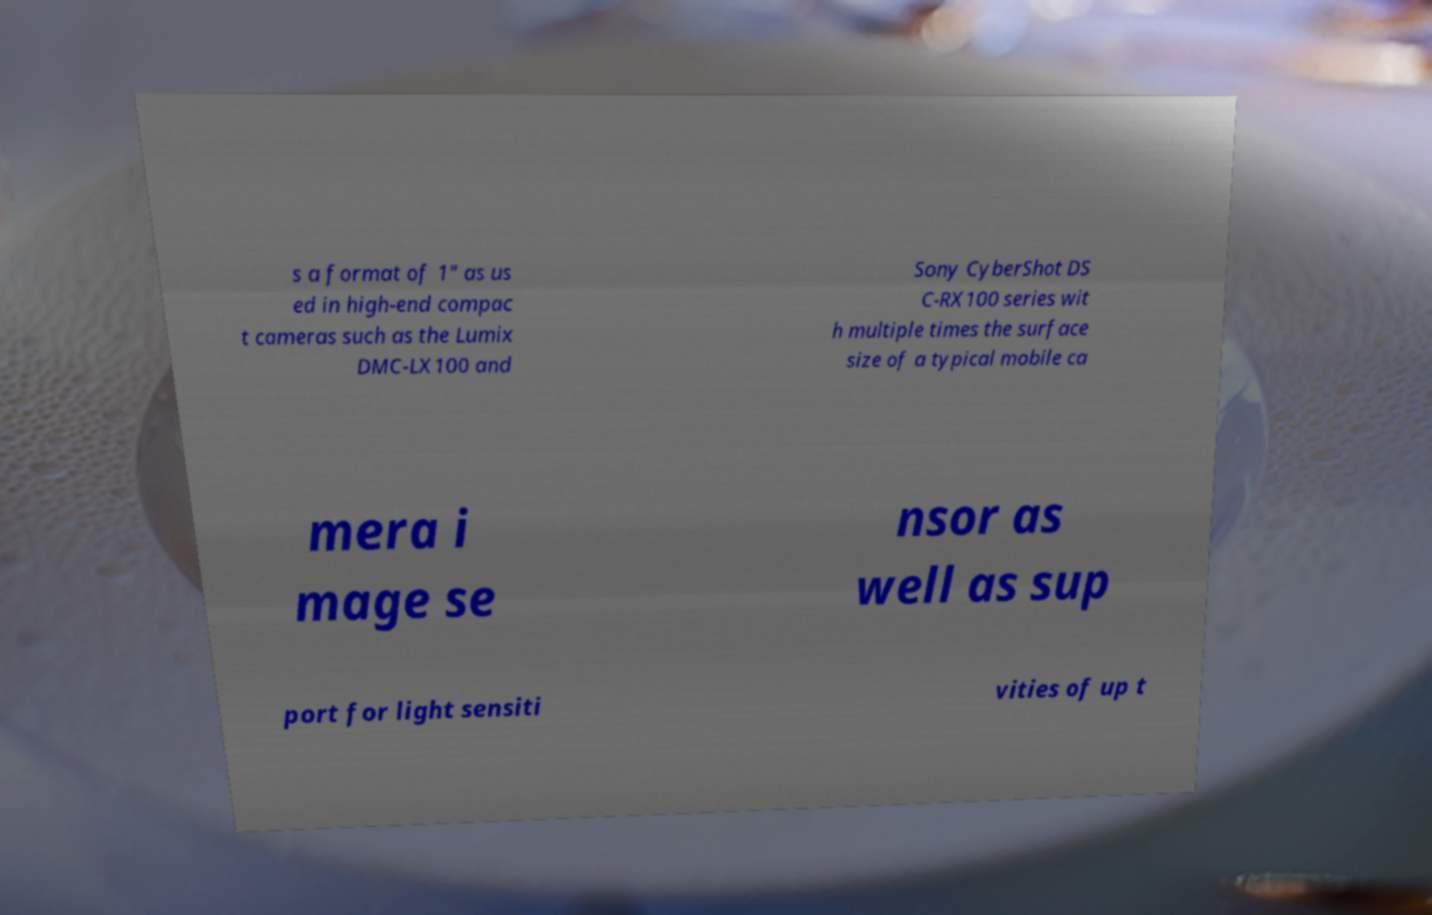Please identify and transcribe the text found in this image. s a format of 1" as us ed in high-end compac t cameras such as the Lumix DMC-LX100 and Sony CyberShot DS C-RX100 series wit h multiple times the surface size of a typical mobile ca mera i mage se nsor as well as sup port for light sensiti vities of up t 